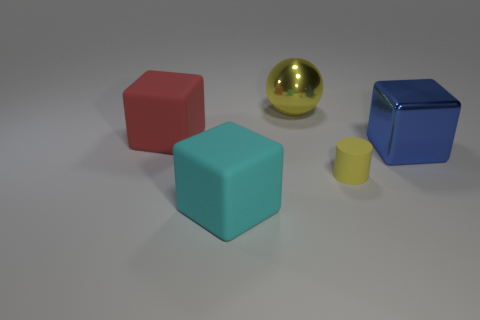Add 4 big blue blocks. How many objects exist? 9 Subtract all cubes. How many objects are left? 2 Add 1 cyan rubber things. How many cyan rubber things are left? 2 Add 5 green rubber cubes. How many green rubber cubes exist? 5 Subtract 0 red balls. How many objects are left? 5 Subtract all metallic blocks. Subtract all big blue metallic objects. How many objects are left? 3 